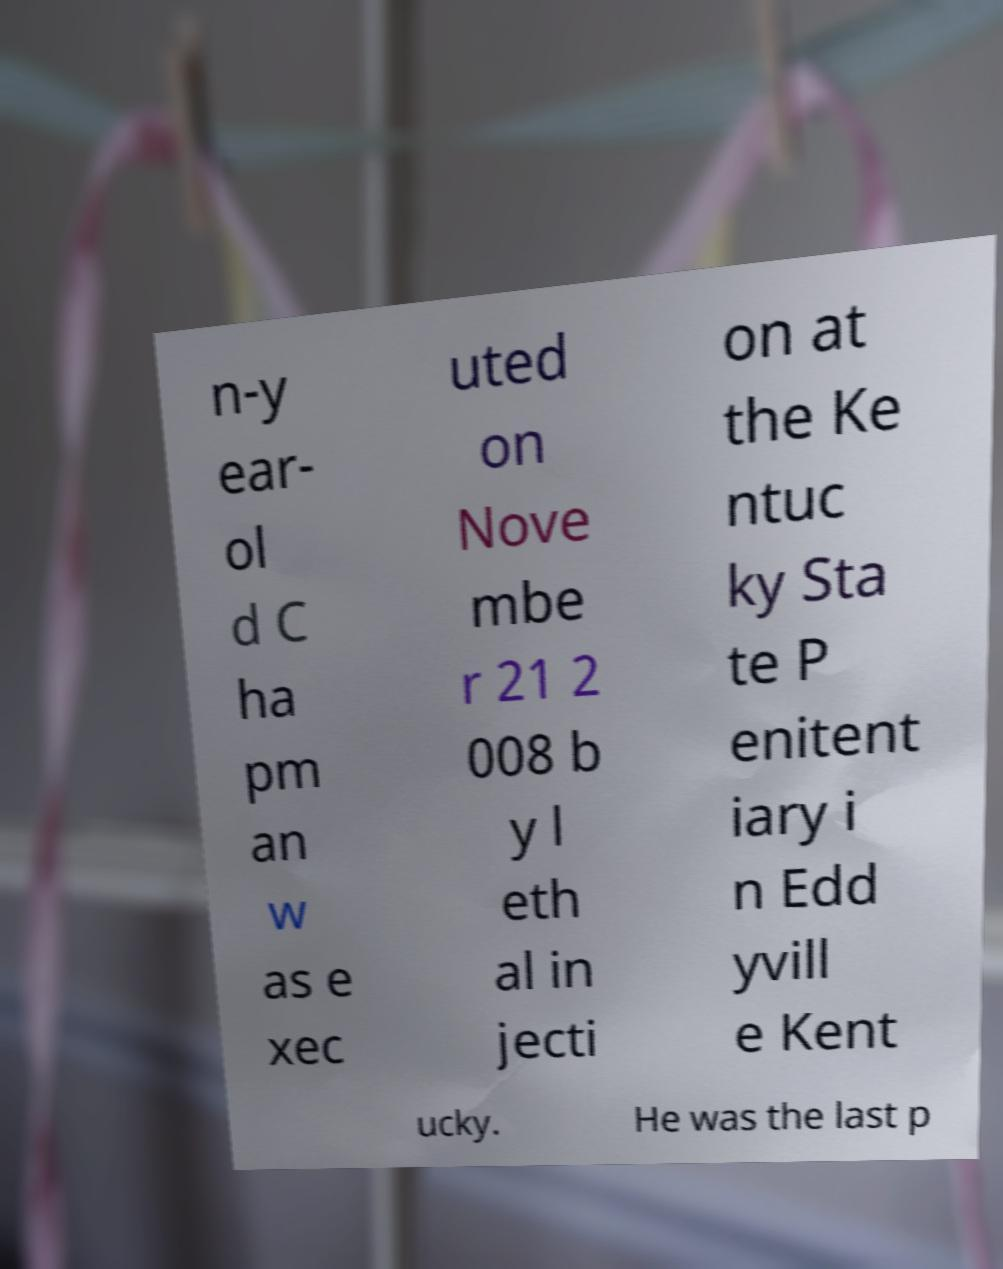Please read and relay the text visible in this image. What does it say? n-y ear- ol d C ha pm an w as e xec uted on Nove mbe r 21 2 008 b y l eth al in jecti on at the Ke ntuc ky Sta te P enitent iary i n Edd yvill e Kent ucky. He was the last p 